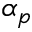Convert formula to latex. <formula><loc_0><loc_0><loc_500><loc_500>\alpha _ { p }</formula> 